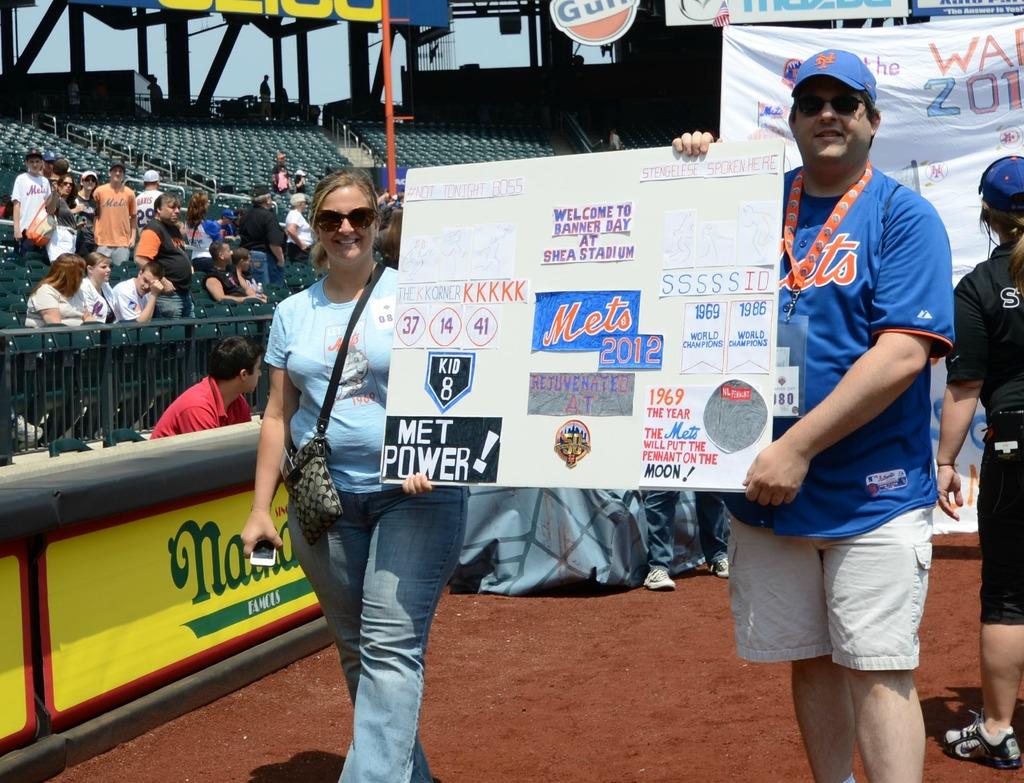What type of power?
Your answer should be compact. Met. What is the team written on the blue background?
Ensure brevity in your answer.  Mets. 